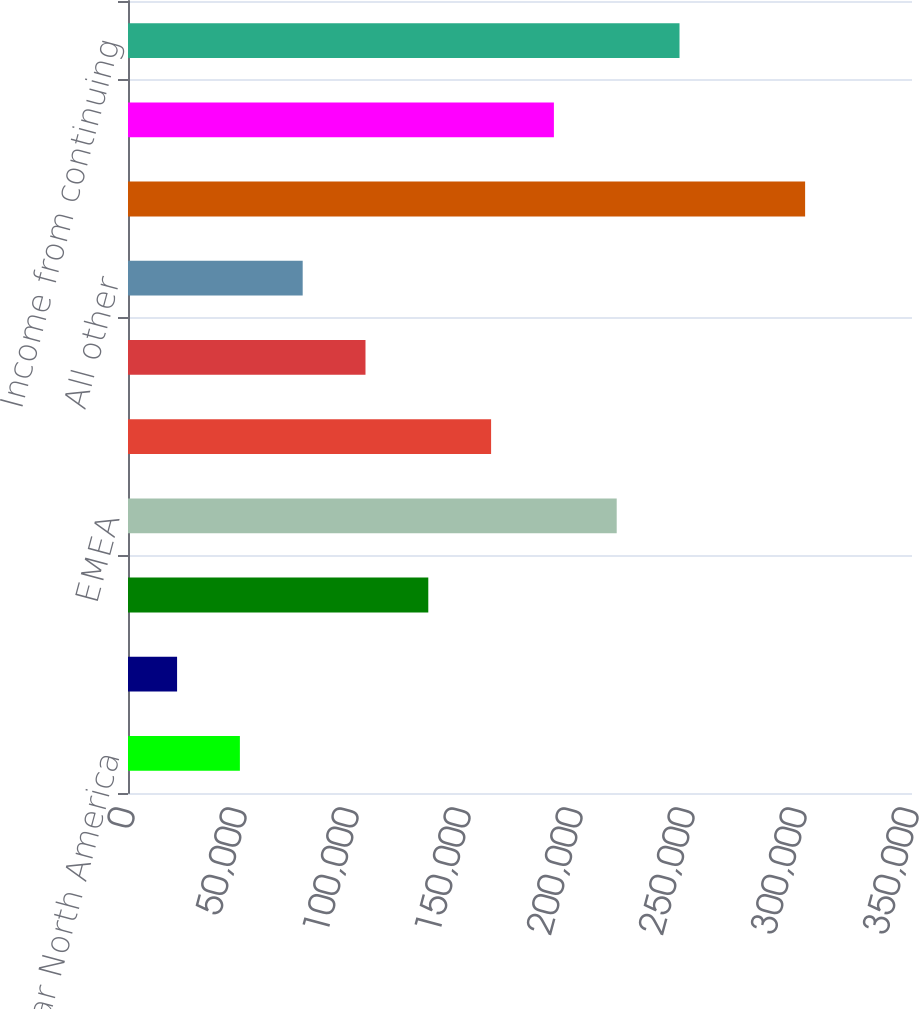Convert chart. <chart><loc_0><loc_0><loc_500><loc_500><bar_chart><fcel>Vascular North America<fcel>Anesthesia/Respiratory North<fcel>Surgical North America<fcel>EMEA<fcel>Asia<fcel>OEM<fcel>All other<fcel>Total segment operating profit<fcel>Unallocated expenses (2)<fcel>Income from continuing<nl><fcel>49947.5<fcel>21910<fcel>134060<fcel>218172<fcel>162098<fcel>106022<fcel>77985<fcel>302285<fcel>190135<fcel>246210<nl></chart> 